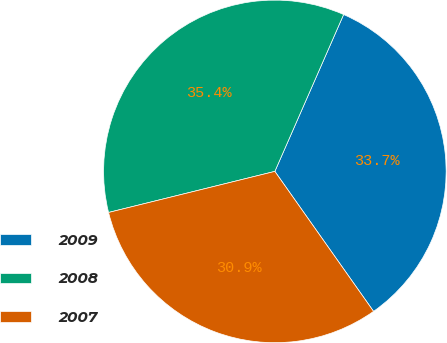Convert chart to OTSL. <chart><loc_0><loc_0><loc_500><loc_500><pie_chart><fcel>2009<fcel>2008<fcel>2007<nl><fcel>33.65%<fcel>35.43%<fcel>30.92%<nl></chart> 